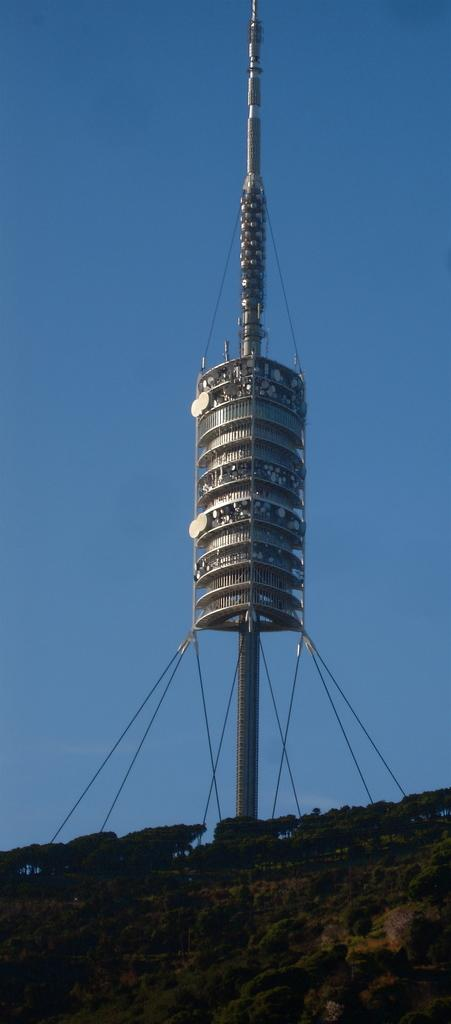What can be seen in the background of the image? The sky is visible in the background of the image. What is the main structure in the image? There is a tower in the image. What type of vegetation is present in the image? There are trees and plants in the image. What objects are used for tying or securing in the image? There are ropes in the image. What type of screw is used to hold the tower together in the image? There is no screw visible in the image, and the tower's construction is not described. What historical event is depicted in the image? The image does not depict any historical event; it features a tower, trees, plants, and ropes. 